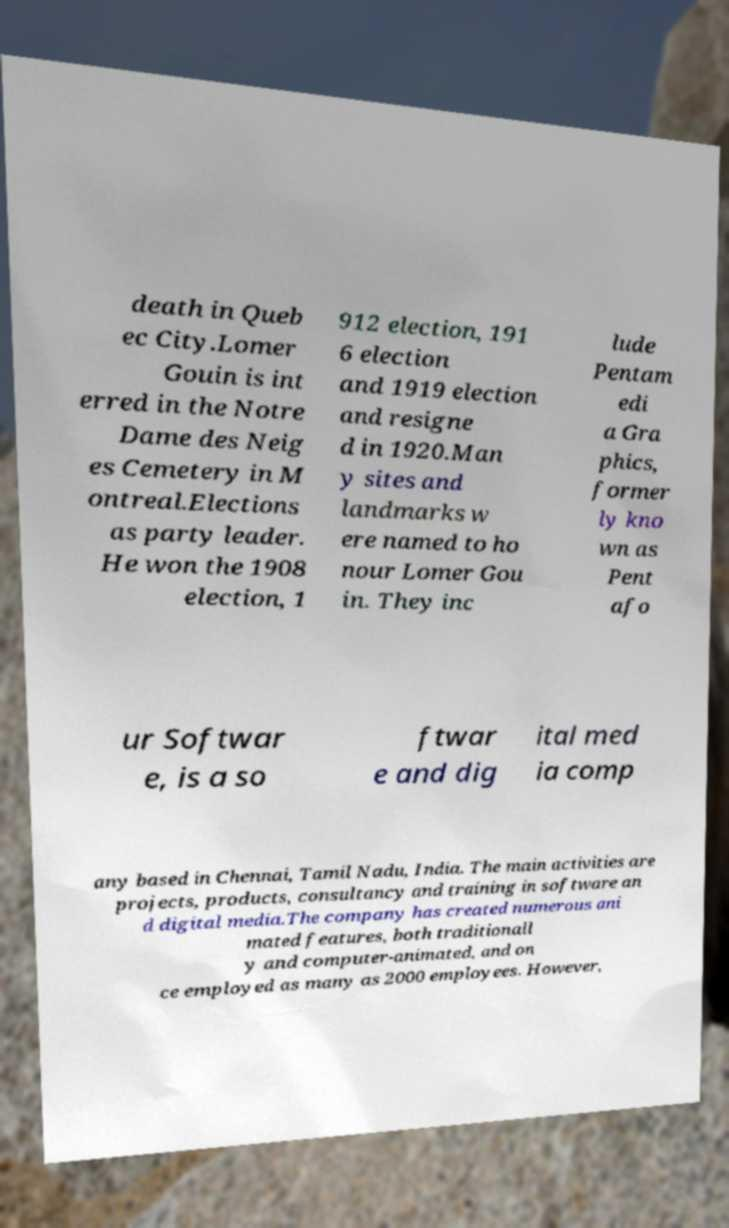Can you read and provide the text displayed in the image?This photo seems to have some interesting text. Can you extract and type it out for me? death in Queb ec City.Lomer Gouin is int erred in the Notre Dame des Neig es Cemetery in M ontreal.Elections as party leader. He won the 1908 election, 1 912 election, 191 6 election and 1919 election and resigne d in 1920.Man y sites and landmarks w ere named to ho nour Lomer Gou in. They inc lude Pentam edi a Gra phics, former ly kno wn as Pent afo ur Softwar e, is a so ftwar e and dig ital med ia comp any based in Chennai, Tamil Nadu, India. The main activities are projects, products, consultancy and training in software an d digital media.The company has created numerous ani mated features, both traditionall y and computer-animated, and on ce employed as many as 2000 employees. However, 